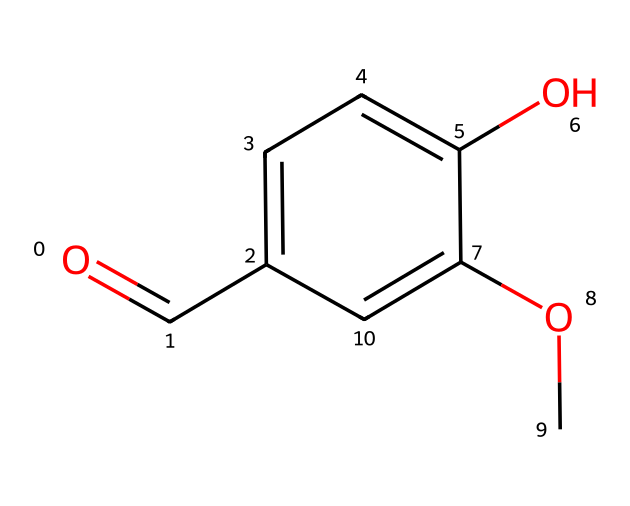What is the functional group present in vanillin? The structure shows a carbonyl group (C=O) located at the end of the molecule, characteristic of aldehydes.
Answer: aldehyde How many oxygen atoms are in the chemical structure of vanillin? By examining the SMILES representation, one can see that there are two distinct oxygen atoms.
Answer: two What type of bond connects the carbonyl carbon to the hydroxyl group? The carbonyl carbon is connected to the hydroxyl oxygen through a single bond (C-O), which is typical for an aldehyde and alcohol combination.
Answer: single What is the molecular formula of vanillin? From the chemical structure, you can deduce that the counts of carbon, hydrogen, and oxygen give a molecular formula of C8H8O3.
Answer: C8H8O3 What structural feature identifies vanillin as an aromatic compound? The presence of a benzene ring (indicated by the alternating double bonds in the structure) classifies it as aromatic.
Answer: benzene ring How many aromatic carbon atoms are present in vanillin? Looking at the chemical structure, there are six carbon atoms involved in the benzene ring, which are aromatic.
Answer: six What property does the aldehyde group confer to vanillin in terms of reactivity? The aldehyde group is known for being reactive and can undergo oxidation, making vanillin capable of participating in various chemical reactions.
Answer: reactive 